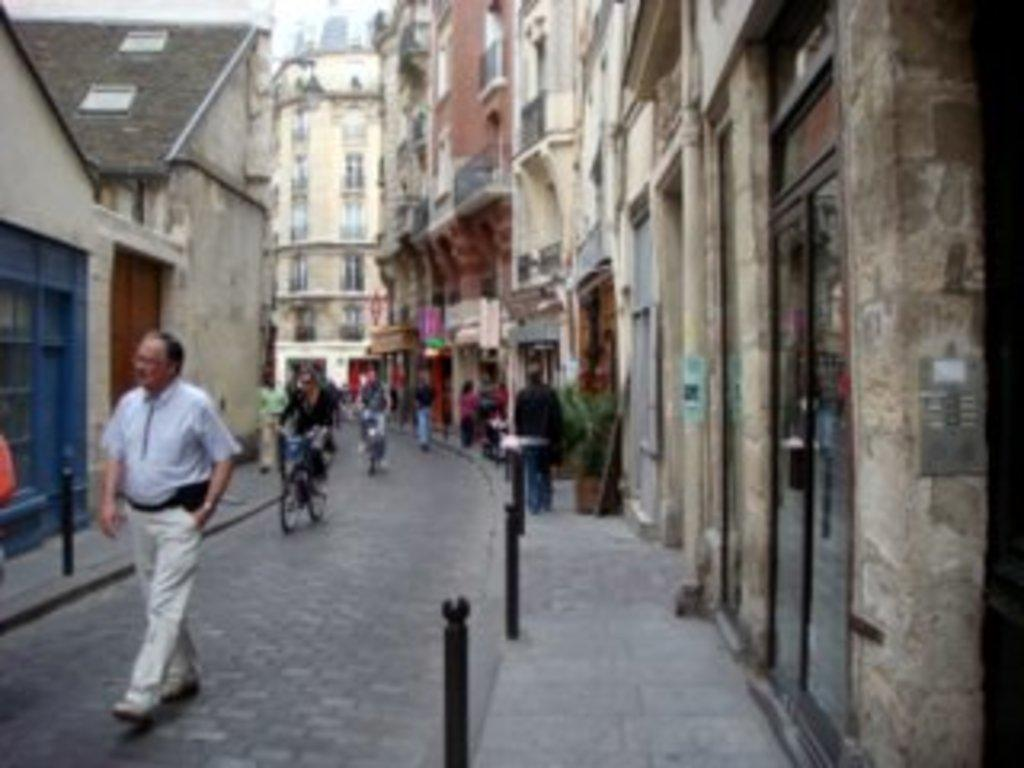What are the people in the image doing? The people in the image are walking on the road and riding bicycles. What can be seen beside the road? Metal poles are visible beside the road. What type of structures are present in the image? There are buildings in the image. Can you describe any other objects in the image? There are some unspecified objects in the image. How much income do the people in the image have? There is no information about the income of the people in the image. --- Facts: 1. There is a person in the image. 2. The person is wearing a hat. 3. The person is holding a book. 4. The person is standing in front of a bookshelf. 5. The bookshelf is filled with books. Absurd Topics: elephant, piano Conversation: What is the main subject in the image? The main subject in the image is a person. What is the person wearing in the image? The person is wearing a hat in the image. What is the person holding in the image? The person is holding a book in the image. What is the person standing in front of in the image? The person is standing in front of a bookshelf in the image. How many books can be seen on the bookshelf in the image? The bookshelf is filled with books in the image. Reasoning: Let's think step by step in order to produce the conversation. We start by identifying the main subject of the image, which is a person. Next, we describe the person's attire, noting that they are wearing a hat. Then, we observe the actions of the person, noting that they are holding a book. After that, we describe the setting where the person is located, which is in front of a bookshelf. Finally, we describe the bookshelf, noting that it is filled with books. Absurd Question/Answer: Can you hear the elephant playing the piano in the image? There is no elephant or piano present in the image. --- Facts: 1. There is a cat in the image. 2. The cat is sitting on a chair. 3. The chair is located near a window. 4. The window has curtains. 5. The cat is looking outside. Absurd Topics: carrot, cake Conversation: What type of animal can be seen in the image? A cat can be seen in the image. What is the cat doing in the image? The cat is sitting on a chair in the image. Where is the chair located in the image? The chair is located near a window in the image. What can be seen on the window in the image? The window has curtains in the image. What is the cat looking at in the image? The cat is looking outside 